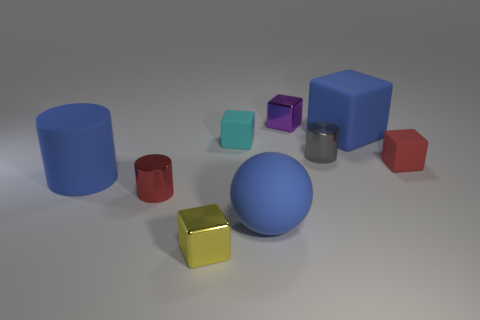Subtract all blue blocks. How many blocks are left? 4 Subtract all blue blocks. How many blocks are left? 4 Add 1 tiny red rubber blocks. How many objects exist? 10 Subtract all yellow spheres. Subtract all blue blocks. How many spheres are left? 1 Subtract all cylinders. How many objects are left? 6 Subtract all large brown spheres. Subtract all rubber spheres. How many objects are left? 8 Add 3 small metal objects. How many small metal objects are left? 7 Add 7 small gray spheres. How many small gray spheres exist? 7 Subtract 1 purple cubes. How many objects are left? 8 